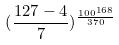<formula> <loc_0><loc_0><loc_500><loc_500>( \frac { 1 2 7 - 4 } { 7 } ) ^ { \frac { 1 0 0 ^ { 1 6 8 } } { 3 7 0 } }</formula> 